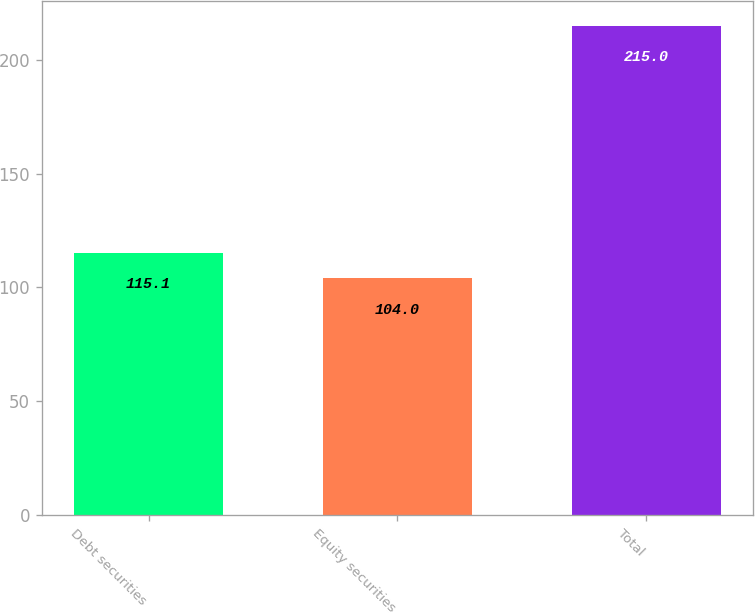Convert chart. <chart><loc_0><loc_0><loc_500><loc_500><bar_chart><fcel>Debt securities<fcel>Equity securities<fcel>Total<nl><fcel>115.1<fcel>104<fcel>215<nl></chart> 